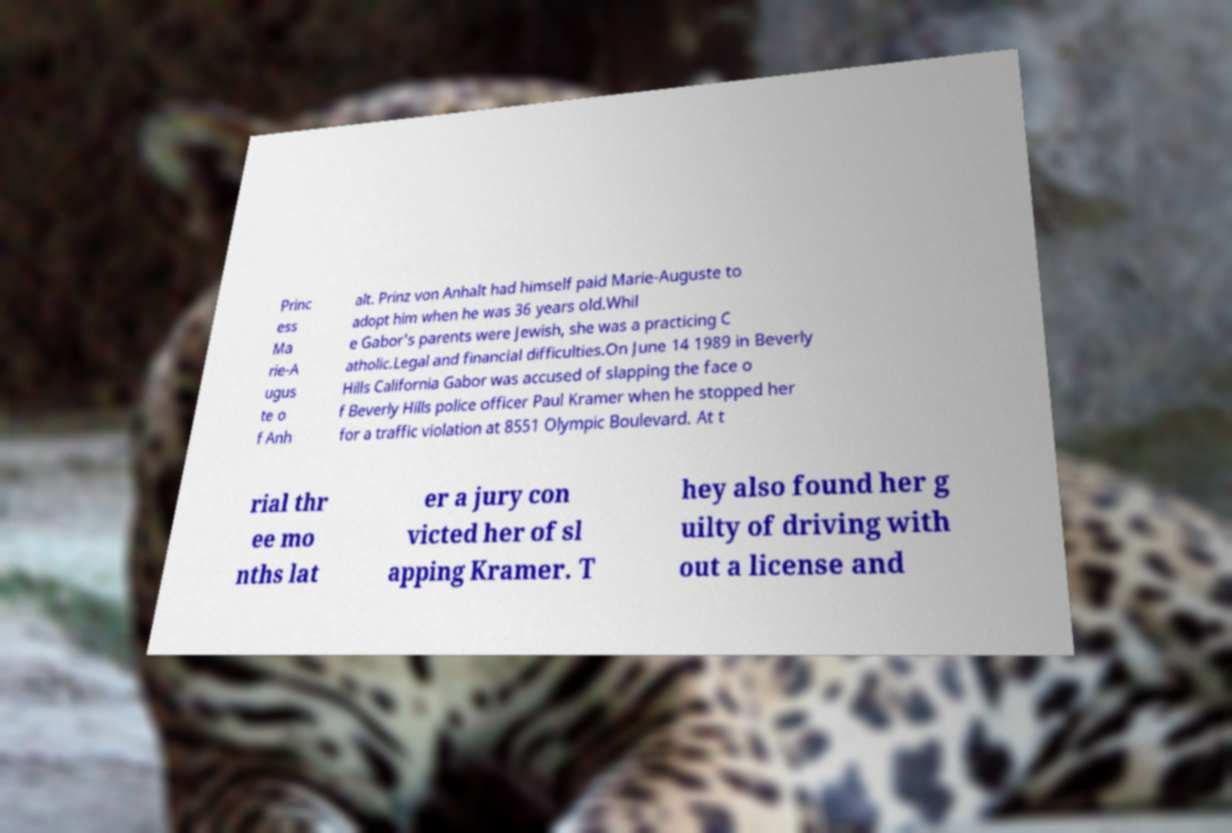Could you extract and type out the text from this image? Princ ess Ma rie-A ugus te o f Anh alt. Prinz von Anhalt had himself paid Marie-Auguste to adopt him when he was 36 years old.Whil e Gabor's parents were Jewish, she was a practicing C atholic.Legal and financial difficulties.On June 14 1989 in Beverly Hills California Gabor was accused of slapping the face o f Beverly Hills police officer Paul Kramer when he stopped her for a traffic violation at 8551 Olympic Boulevard. At t rial thr ee mo nths lat er a jury con victed her of sl apping Kramer. T hey also found her g uilty of driving with out a license and 